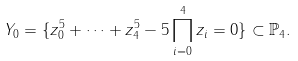Convert formula to latex. <formula><loc_0><loc_0><loc_500><loc_500>Y _ { 0 } = \{ z _ { 0 } ^ { 5 } + \cdots + z _ { 4 } ^ { 5 } - 5 \prod _ { i = 0 } ^ { 4 } z _ { i } = 0 \} \subset { \mathbb { P } } _ { 4 } .</formula> 